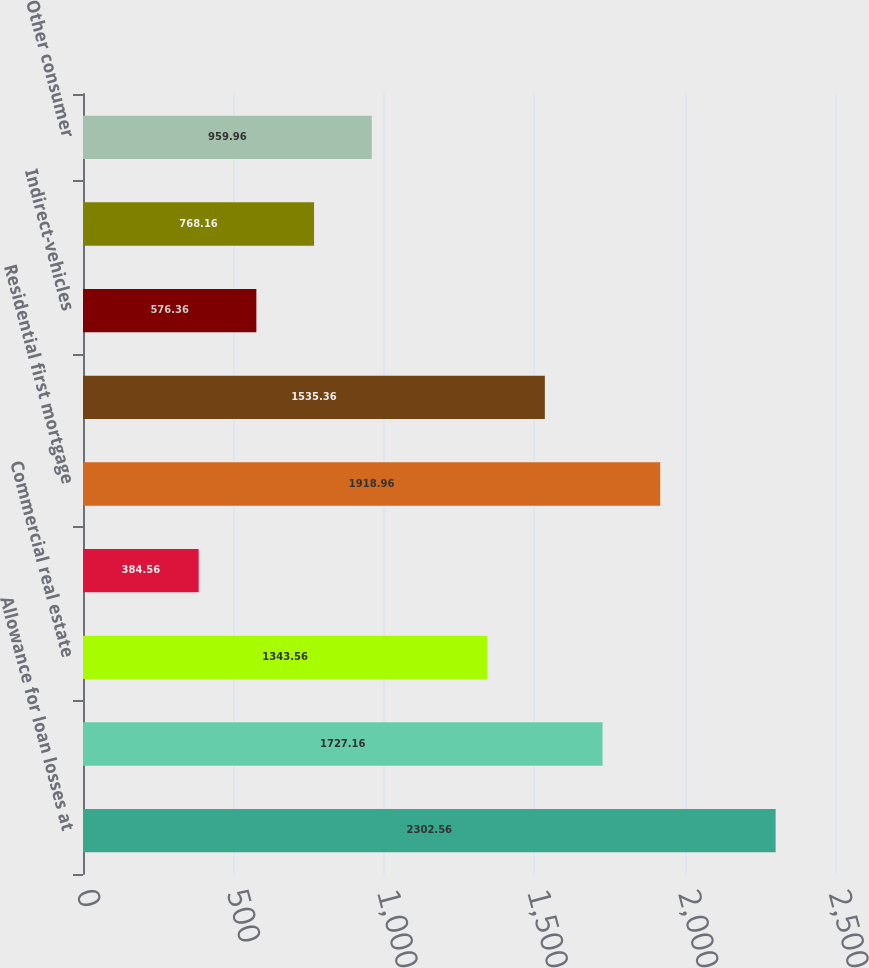<chart> <loc_0><loc_0><loc_500><loc_500><bar_chart><fcel>Allowance for loan losses at<fcel>Commercial and industrial<fcel>Commercial real estate<fcel>Commercial investor real<fcel>Residential first mortgage<fcel>Home equity<fcel>Indirect-vehicles<fcel>Consumer credit card<fcel>Other consumer<nl><fcel>2302.56<fcel>1727.16<fcel>1343.56<fcel>384.56<fcel>1918.96<fcel>1535.36<fcel>576.36<fcel>768.16<fcel>959.96<nl></chart> 